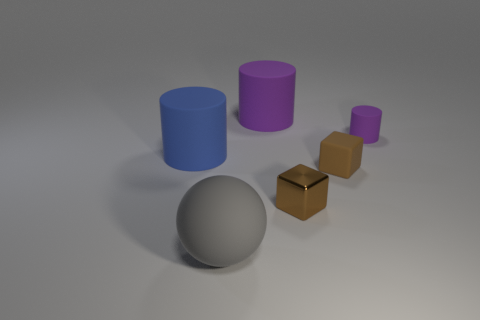Are there the same number of rubber balls right of the tiny brown matte block and big things that are behind the gray object?
Offer a terse response. No. The sphere is what color?
Provide a succinct answer. Gray. What number of objects are tiny things that are on the left side of the tiny purple matte object or brown metal blocks?
Your answer should be compact. 2. There is a blue cylinder that is behind the big gray matte sphere; is it the same size as the purple object that is left of the metal thing?
Ensure brevity in your answer.  Yes. Are there any other things that have the same material as the small purple thing?
Your answer should be compact. Yes. How many things are either objects in front of the small matte cylinder or large objects right of the big gray sphere?
Your answer should be compact. 5. Do the gray sphere and the big cylinder that is to the left of the large purple cylinder have the same material?
Ensure brevity in your answer.  Yes. The rubber object that is on the left side of the shiny cube and right of the big gray sphere has what shape?
Provide a short and direct response. Cylinder. How many other things are the same color as the ball?
Ensure brevity in your answer.  0. What shape is the gray object?
Provide a short and direct response. Sphere. 